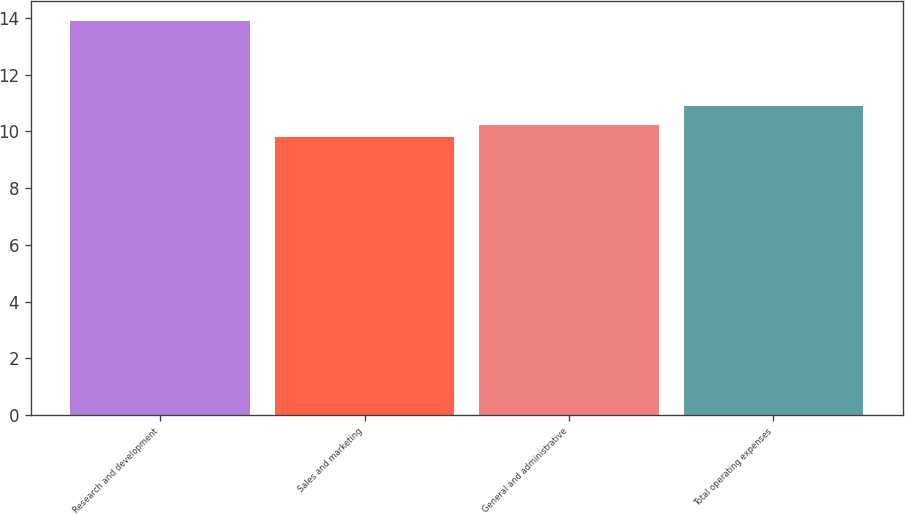Convert chart to OTSL. <chart><loc_0><loc_0><loc_500><loc_500><bar_chart><fcel>Research and development<fcel>Sales and marketing<fcel>General and administrative<fcel>Total operating expenses<nl><fcel>13.9<fcel>9.8<fcel>10.21<fcel>10.9<nl></chart> 